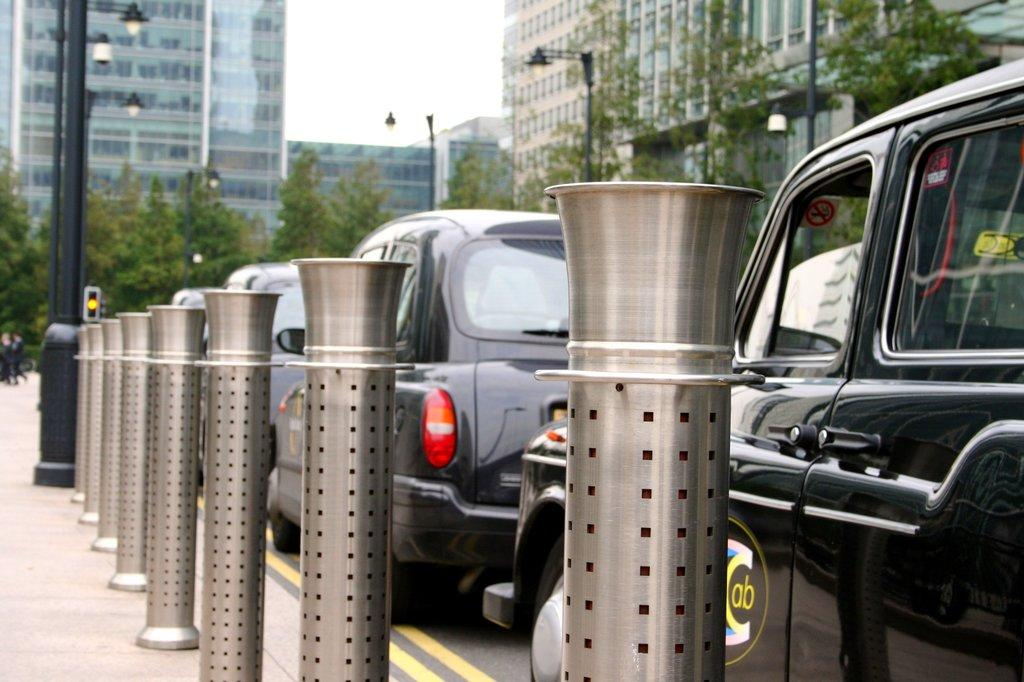Where was the image taken? The image was taken on the road. What can be seen in the center of the image? There are cars on the road in the center of the image. What is located on the left side of the image? There are poles on the left side of the image. What can be seen in the background of the image? There are trees and buildings in the background of the image. What grade does the history book on the road receive in the image? There is no history book or any reference to a grade in the image. 